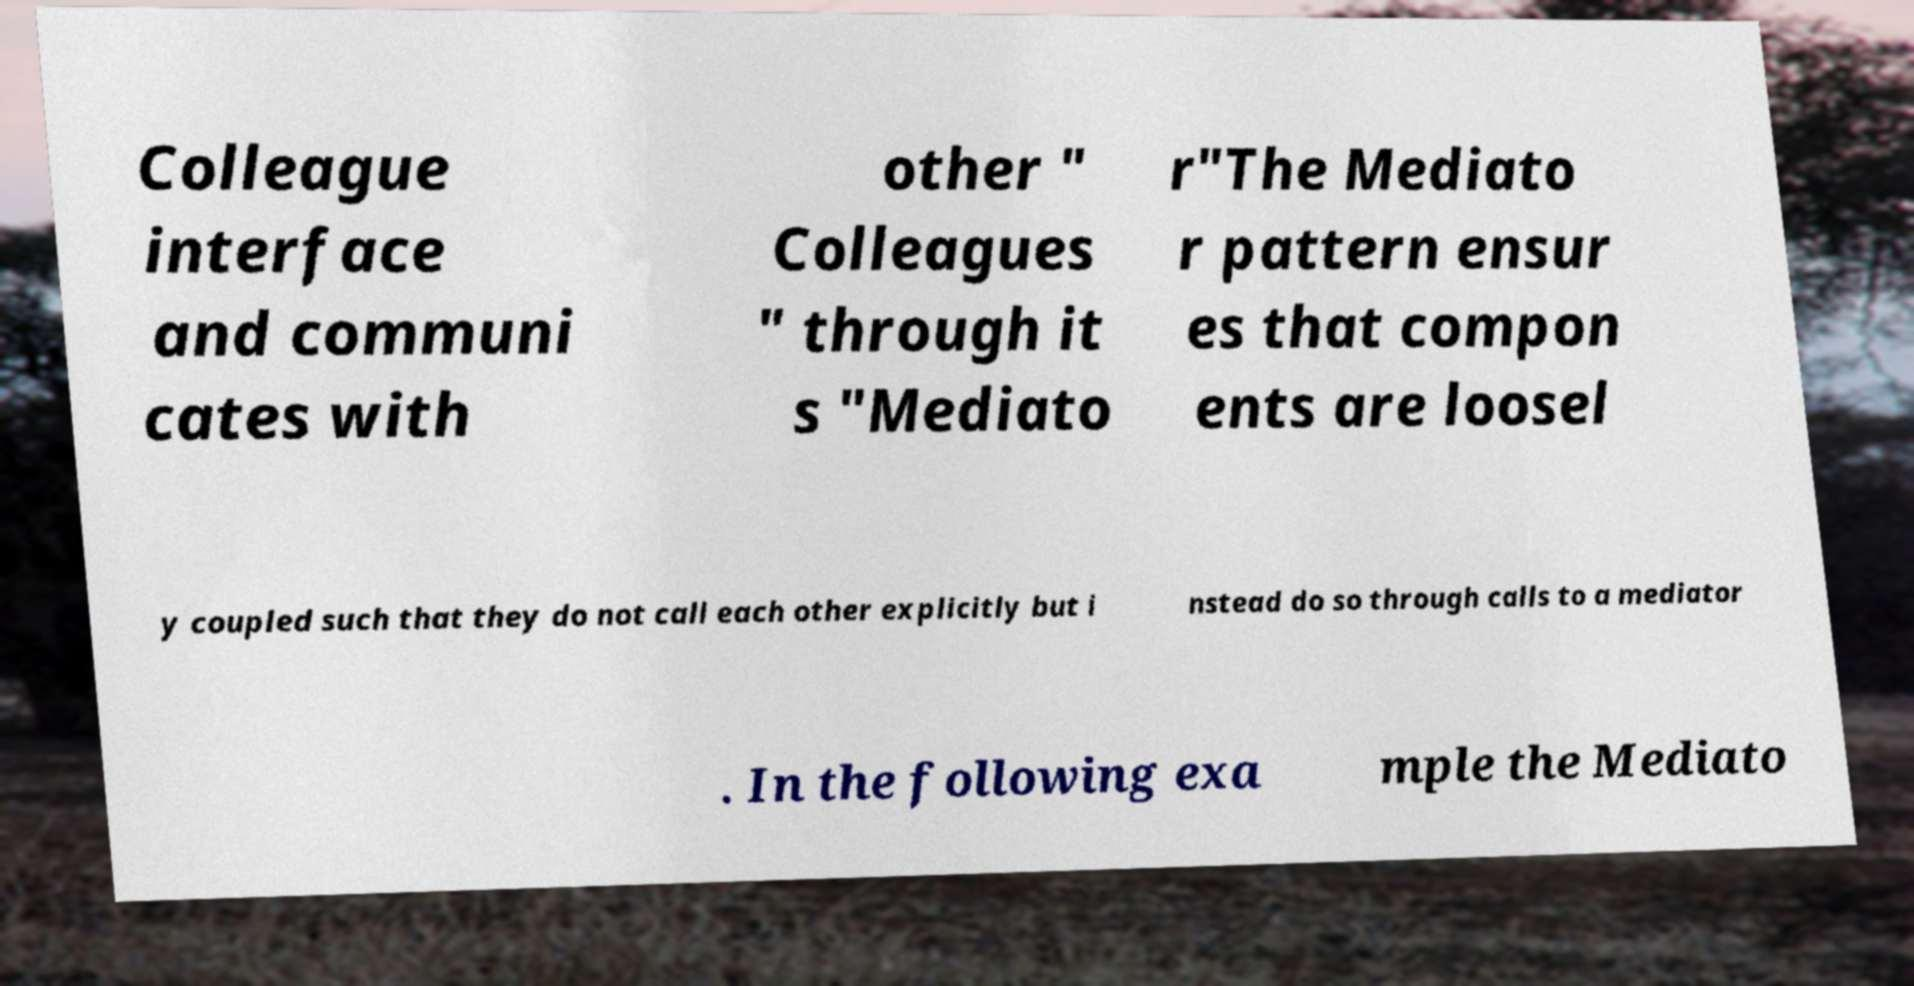I need the written content from this picture converted into text. Can you do that? Colleague interface and communi cates with other " Colleagues " through it s "Mediato r"The Mediato r pattern ensur es that compon ents are loosel y coupled such that they do not call each other explicitly but i nstead do so through calls to a mediator . In the following exa mple the Mediato 